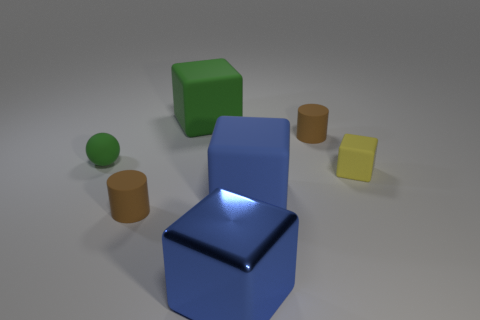The blue matte block has what size?
Provide a short and direct response. Large. Is there a yellow object of the same shape as the big blue metallic thing?
Make the answer very short. Yes. There is a small brown cylinder that is in front of the tiny brown matte cylinder that is behind the small yellow block; are there any blue shiny things to the left of it?
Ensure brevity in your answer.  No. Is the number of cubes that are to the left of the tiny yellow thing greater than the number of big blue metallic cubes that are behind the large blue rubber thing?
Your answer should be compact. Yes. What material is the blue object that is the same size as the blue shiny block?
Keep it short and to the point. Rubber. How many big objects are either yellow things or blocks?
Provide a short and direct response. 3. Does the small green object have the same shape as the large green rubber thing?
Your answer should be very brief. No. How many objects are both in front of the green cube and on the left side of the large metallic block?
Your answer should be compact. 2. Is there anything else that has the same color as the tiny ball?
Give a very brief answer. Yes. The tiny green thing that is the same material as the small yellow thing is what shape?
Your response must be concise. Sphere. 